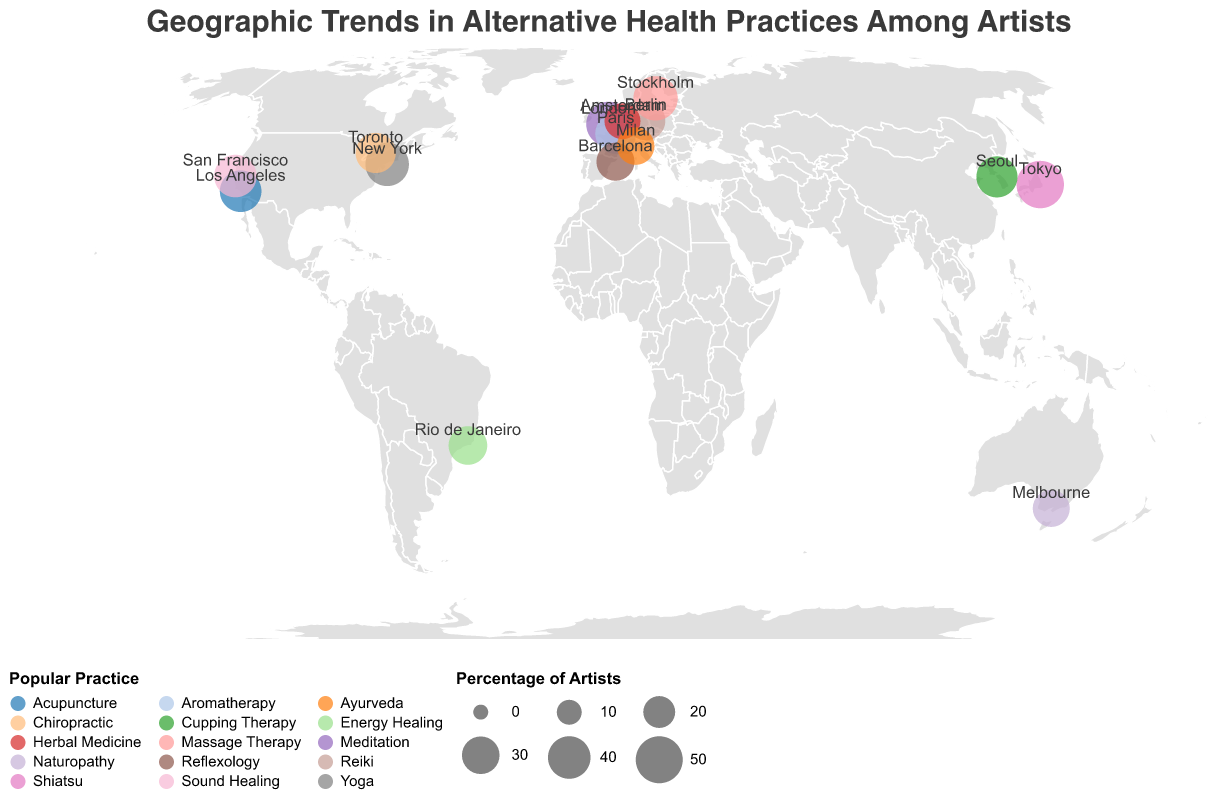What is the most popular alternative health practice among artists in New York? By looking at the plot, you can identify New York and see the practice listed is Yoga, with a percentage of artists practicing it.
Answer: Yoga Which city has the highest percentage of artists practicing an alternative or holistic health practice? Tokyo has the highest percentage of artists practicing a specific health practice, which is Shiatsu, at 51%.
Answer: Tokyo What percentage of artists in Paris practice Aromatherapy? By locating Paris on the map, you can see that 36% of artists practice Aromatherapy.
Answer: 36% How many cities have more than 40% of artists practicing their respective alternative health practices? The cities with more than 40% are New York (42%), San Francisco (40%), London (45%), Stockholm (44%), and Tokyo (51%). Thus, there are 5 such cities.
Answer: 5 What is the average percentage of artists practicing the listed health practices in all cities? Sum all percentages: (42 + 38 + 45 + 36 + 33 + 51 + 29 + 31 + 35 + 27 + 40 + 44 + 30 + 37 + 32) = 550. There are 15 cities, so 550 / 15 = 36.67.
Answer: 36.67 Which cities practice a form of therapy related to traditional Chinese medicine? Los Angeles (Acupuncture), Seoul (Cupping Therapy) can be associated with traditional Chinese medicine.
Answer: Los Angeles and Seoul What is the difference in the percentage of artists practicing in Toronto and Berlin? Artists in Toronto practice Chiropractic at 35%, and in Berlin practice Reiki at 33%. The difference is 35 - 33 = 2.
Answer: 2 Which practice is more popular in Stockholm compared to Toronto? In Stockholm, Massage Therapy is practiced by 44% of artists, whereas in Toronto, Chiropractic is practiced by 35%. Massage Therapy is more popular.
Answer: Massage Therapy Which city is associated with the practice of Sound Healing, and what is the percentage of artists practicing it there? By referring to the plot, Sound Healing is practiced in San Francisco with 40% of artists involved.
Answer: San Francisco, 40% How many cities in Europe are included in the data, and which practices are popular there? European cities: London (Meditation), Paris (Aromatherapy), Berlin (Reiki), Barcelona (Reflexology), Amsterdam (Herbal Medicine), Stockholm (Massage Therapy), Milan (Ayurveda). There are 7 cities.
Answer: 7, practices listed above 